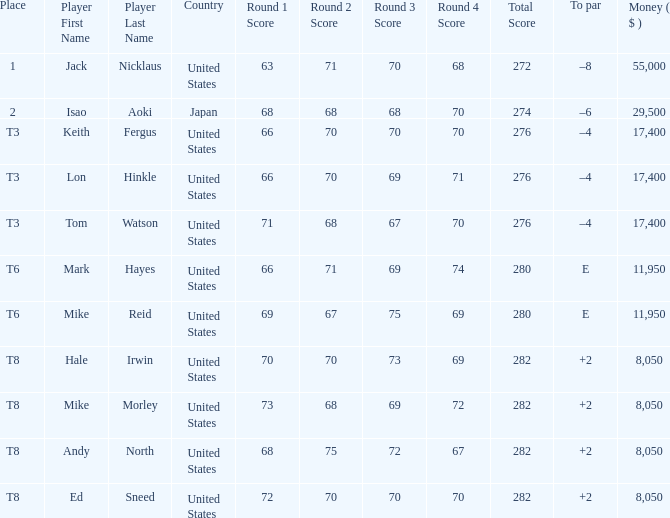What country has the score og 66-70-69-71=276? United States. 